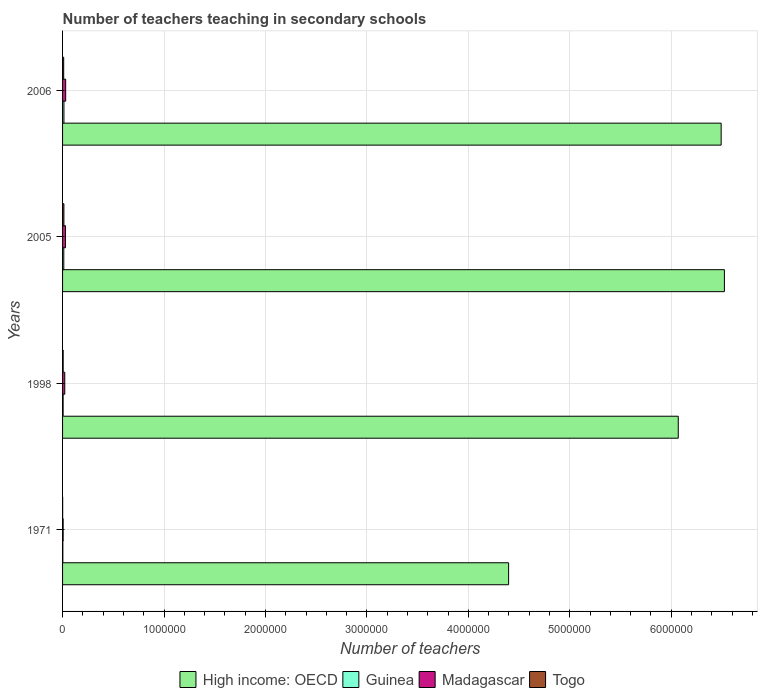How many different coloured bars are there?
Provide a short and direct response. 4. Are the number of bars per tick equal to the number of legend labels?
Give a very brief answer. Yes. Are the number of bars on each tick of the Y-axis equal?
Offer a terse response. Yes. What is the label of the 4th group of bars from the top?
Your answer should be compact. 1971. What is the number of teachers teaching in secondary schools in High income: OECD in 2005?
Give a very brief answer. 6.52e+06. Across all years, what is the maximum number of teachers teaching in secondary schools in Guinea?
Offer a terse response. 1.35e+04. Across all years, what is the minimum number of teachers teaching in secondary schools in Madagascar?
Your response must be concise. 5709. What is the total number of teachers teaching in secondary schools in Guinea in the graph?
Provide a short and direct response. 3.40e+04. What is the difference between the number of teachers teaching in secondary schools in Madagascar in 1998 and that in 2006?
Provide a succinct answer. -9016. What is the difference between the number of teachers teaching in secondary schools in Togo in 2006 and the number of teachers teaching in secondary schools in High income: OECD in 1998?
Ensure brevity in your answer.  -6.06e+06. What is the average number of teachers teaching in secondary schools in Guinea per year?
Your answer should be compact. 8506. In the year 2006, what is the difference between the number of teachers teaching in secondary schools in Madagascar and number of teachers teaching in secondary schools in Guinea?
Keep it short and to the point. 1.72e+04. In how many years, is the number of teachers teaching in secondary schools in Guinea greater than 4200000 ?
Ensure brevity in your answer.  0. What is the ratio of the number of teachers teaching in secondary schools in Togo in 2005 to that in 2006?
Provide a short and direct response. 1.2. Is the number of teachers teaching in secondary schools in Guinea in 1998 less than that in 2005?
Give a very brief answer. Yes. What is the difference between the highest and the second highest number of teachers teaching in secondary schools in High income: OECD?
Ensure brevity in your answer.  3.19e+04. What is the difference between the highest and the lowest number of teachers teaching in secondary schools in Togo?
Provide a short and direct response. 1.24e+04. Is it the case that in every year, the sum of the number of teachers teaching in secondary schools in Madagascar and number of teachers teaching in secondary schools in Togo is greater than the sum of number of teachers teaching in secondary schools in Guinea and number of teachers teaching in secondary schools in High income: OECD?
Make the answer very short. No. What does the 1st bar from the top in 1971 represents?
Make the answer very short. Togo. What does the 2nd bar from the bottom in 1971 represents?
Offer a terse response. Guinea. How many bars are there?
Your response must be concise. 16. How many years are there in the graph?
Give a very brief answer. 4. Does the graph contain any zero values?
Provide a short and direct response. No. Does the graph contain grids?
Your answer should be compact. Yes. Where does the legend appear in the graph?
Provide a succinct answer. Bottom center. What is the title of the graph?
Your answer should be very brief. Number of teachers teaching in secondary schools. What is the label or title of the X-axis?
Give a very brief answer. Number of teachers. What is the label or title of the Y-axis?
Offer a very short reply. Years. What is the Number of teachers of High income: OECD in 1971?
Make the answer very short. 4.40e+06. What is the Number of teachers in Guinea in 1971?
Your answer should be compact. 2785. What is the Number of teachers of Madagascar in 1971?
Your answer should be compact. 5709. What is the Number of teachers of Togo in 1971?
Your response must be concise. 880. What is the Number of teachers in High income: OECD in 1998?
Provide a succinct answer. 6.07e+06. What is the Number of teachers in Guinea in 1998?
Offer a very short reply. 5560. What is the Number of teachers in Madagascar in 1998?
Make the answer very short. 2.17e+04. What is the Number of teachers in Togo in 1998?
Offer a very short reply. 5962. What is the Number of teachers in High income: OECD in 2005?
Provide a short and direct response. 6.52e+06. What is the Number of teachers in Guinea in 2005?
Offer a terse response. 1.22e+04. What is the Number of teachers in Madagascar in 2005?
Provide a succinct answer. 2.88e+04. What is the Number of teachers of Togo in 2005?
Give a very brief answer. 1.33e+04. What is the Number of teachers of High income: OECD in 2006?
Keep it short and to the point. 6.49e+06. What is the Number of teachers of Guinea in 2006?
Provide a succinct answer. 1.35e+04. What is the Number of teachers in Madagascar in 2006?
Ensure brevity in your answer.  3.07e+04. What is the Number of teachers of Togo in 2006?
Provide a succinct answer. 1.11e+04. Across all years, what is the maximum Number of teachers in High income: OECD?
Ensure brevity in your answer.  6.52e+06. Across all years, what is the maximum Number of teachers in Guinea?
Make the answer very short. 1.35e+04. Across all years, what is the maximum Number of teachers of Madagascar?
Provide a short and direct response. 3.07e+04. Across all years, what is the maximum Number of teachers of Togo?
Provide a succinct answer. 1.33e+04. Across all years, what is the minimum Number of teachers of High income: OECD?
Your answer should be compact. 4.40e+06. Across all years, what is the minimum Number of teachers in Guinea?
Provide a succinct answer. 2785. Across all years, what is the minimum Number of teachers in Madagascar?
Keep it short and to the point. 5709. Across all years, what is the minimum Number of teachers of Togo?
Keep it short and to the point. 880. What is the total Number of teachers in High income: OECD in the graph?
Make the answer very short. 2.35e+07. What is the total Number of teachers in Guinea in the graph?
Make the answer very short. 3.40e+04. What is the total Number of teachers of Madagascar in the graph?
Provide a short and direct response. 8.69e+04. What is the total Number of teachers in Togo in the graph?
Offer a very short reply. 3.12e+04. What is the difference between the Number of teachers of High income: OECD in 1971 and that in 1998?
Offer a terse response. -1.67e+06. What is the difference between the Number of teachers in Guinea in 1971 and that in 1998?
Make the answer very short. -2775. What is the difference between the Number of teachers in Madagascar in 1971 and that in 1998?
Your answer should be very brief. -1.60e+04. What is the difference between the Number of teachers in Togo in 1971 and that in 1998?
Give a very brief answer. -5082. What is the difference between the Number of teachers of High income: OECD in 1971 and that in 2005?
Provide a short and direct response. -2.13e+06. What is the difference between the Number of teachers in Guinea in 1971 and that in 2005?
Give a very brief answer. -9417. What is the difference between the Number of teachers of Madagascar in 1971 and that in 2005?
Provide a short and direct response. -2.31e+04. What is the difference between the Number of teachers in Togo in 1971 and that in 2005?
Provide a short and direct response. -1.24e+04. What is the difference between the Number of teachers of High income: OECD in 1971 and that in 2006?
Offer a terse response. -2.10e+06. What is the difference between the Number of teachers of Guinea in 1971 and that in 2006?
Give a very brief answer. -1.07e+04. What is the difference between the Number of teachers in Madagascar in 1971 and that in 2006?
Provide a succinct answer. -2.50e+04. What is the difference between the Number of teachers in Togo in 1971 and that in 2006?
Give a very brief answer. -1.02e+04. What is the difference between the Number of teachers of High income: OECD in 1998 and that in 2005?
Your answer should be very brief. -4.55e+05. What is the difference between the Number of teachers in Guinea in 1998 and that in 2005?
Keep it short and to the point. -6642. What is the difference between the Number of teachers of Madagascar in 1998 and that in 2005?
Offer a terse response. -7148. What is the difference between the Number of teachers in Togo in 1998 and that in 2005?
Make the answer very short. -7297. What is the difference between the Number of teachers of High income: OECD in 1998 and that in 2006?
Ensure brevity in your answer.  -4.23e+05. What is the difference between the Number of teachers of Guinea in 1998 and that in 2006?
Keep it short and to the point. -7917. What is the difference between the Number of teachers of Madagascar in 1998 and that in 2006?
Provide a succinct answer. -9016. What is the difference between the Number of teachers of Togo in 1998 and that in 2006?
Provide a succinct answer. -5105. What is the difference between the Number of teachers in High income: OECD in 2005 and that in 2006?
Your answer should be very brief. 3.19e+04. What is the difference between the Number of teachers in Guinea in 2005 and that in 2006?
Keep it short and to the point. -1275. What is the difference between the Number of teachers in Madagascar in 2005 and that in 2006?
Ensure brevity in your answer.  -1868. What is the difference between the Number of teachers in Togo in 2005 and that in 2006?
Make the answer very short. 2192. What is the difference between the Number of teachers of High income: OECD in 1971 and the Number of teachers of Guinea in 1998?
Offer a very short reply. 4.39e+06. What is the difference between the Number of teachers of High income: OECD in 1971 and the Number of teachers of Madagascar in 1998?
Offer a very short reply. 4.38e+06. What is the difference between the Number of teachers of High income: OECD in 1971 and the Number of teachers of Togo in 1998?
Give a very brief answer. 4.39e+06. What is the difference between the Number of teachers in Guinea in 1971 and the Number of teachers in Madagascar in 1998?
Ensure brevity in your answer.  -1.89e+04. What is the difference between the Number of teachers of Guinea in 1971 and the Number of teachers of Togo in 1998?
Your answer should be compact. -3177. What is the difference between the Number of teachers in Madagascar in 1971 and the Number of teachers in Togo in 1998?
Provide a succinct answer. -253. What is the difference between the Number of teachers of High income: OECD in 1971 and the Number of teachers of Guinea in 2005?
Keep it short and to the point. 4.38e+06. What is the difference between the Number of teachers of High income: OECD in 1971 and the Number of teachers of Madagascar in 2005?
Ensure brevity in your answer.  4.37e+06. What is the difference between the Number of teachers in High income: OECD in 1971 and the Number of teachers in Togo in 2005?
Offer a very short reply. 4.38e+06. What is the difference between the Number of teachers of Guinea in 1971 and the Number of teachers of Madagascar in 2005?
Provide a succinct answer. -2.60e+04. What is the difference between the Number of teachers of Guinea in 1971 and the Number of teachers of Togo in 2005?
Offer a terse response. -1.05e+04. What is the difference between the Number of teachers in Madagascar in 1971 and the Number of teachers in Togo in 2005?
Ensure brevity in your answer.  -7550. What is the difference between the Number of teachers in High income: OECD in 1971 and the Number of teachers in Guinea in 2006?
Make the answer very short. 4.38e+06. What is the difference between the Number of teachers in High income: OECD in 1971 and the Number of teachers in Madagascar in 2006?
Ensure brevity in your answer.  4.37e+06. What is the difference between the Number of teachers of High income: OECD in 1971 and the Number of teachers of Togo in 2006?
Make the answer very short. 4.39e+06. What is the difference between the Number of teachers in Guinea in 1971 and the Number of teachers in Madagascar in 2006?
Your answer should be very brief. -2.79e+04. What is the difference between the Number of teachers in Guinea in 1971 and the Number of teachers in Togo in 2006?
Make the answer very short. -8282. What is the difference between the Number of teachers in Madagascar in 1971 and the Number of teachers in Togo in 2006?
Give a very brief answer. -5358. What is the difference between the Number of teachers of High income: OECD in 1998 and the Number of teachers of Guinea in 2005?
Offer a terse response. 6.06e+06. What is the difference between the Number of teachers of High income: OECD in 1998 and the Number of teachers of Madagascar in 2005?
Offer a very short reply. 6.04e+06. What is the difference between the Number of teachers in High income: OECD in 1998 and the Number of teachers in Togo in 2005?
Your answer should be very brief. 6.06e+06. What is the difference between the Number of teachers in Guinea in 1998 and the Number of teachers in Madagascar in 2005?
Make the answer very short. -2.33e+04. What is the difference between the Number of teachers of Guinea in 1998 and the Number of teachers of Togo in 2005?
Ensure brevity in your answer.  -7699. What is the difference between the Number of teachers of Madagascar in 1998 and the Number of teachers of Togo in 2005?
Offer a terse response. 8411. What is the difference between the Number of teachers of High income: OECD in 1998 and the Number of teachers of Guinea in 2006?
Offer a very short reply. 6.06e+06. What is the difference between the Number of teachers of High income: OECD in 1998 and the Number of teachers of Madagascar in 2006?
Your response must be concise. 6.04e+06. What is the difference between the Number of teachers of High income: OECD in 1998 and the Number of teachers of Togo in 2006?
Your answer should be very brief. 6.06e+06. What is the difference between the Number of teachers of Guinea in 1998 and the Number of teachers of Madagascar in 2006?
Give a very brief answer. -2.51e+04. What is the difference between the Number of teachers in Guinea in 1998 and the Number of teachers in Togo in 2006?
Ensure brevity in your answer.  -5507. What is the difference between the Number of teachers in Madagascar in 1998 and the Number of teachers in Togo in 2006?
Provide a succinct answer. 1.06e+04. What is the difference between the Number of teachers of High income: OECD in 2005 and the Number of teachers of Guinea in 2006?
Your response must be concise. 6.51e+06. What is the difference between the Number of teachers of High income: OECD in 2005 and the Number of teachers of Madagascar in 2006?
Offer a terse response. 6.49e+06. What is the difference between the Number of teachers of High income: OECD in 2005 and the Number of teachers of Togo in 2006?
Keep it short and to the point. 6.51e+06. What is the difference between the Number of teachers in Guinea in 2005 and the Number of teachers in Madagascar in 2006?
Your answer should be very brief. -1.85e+04. What is the difference between the Number of teachers in Guinea in 2005 and the Number of teachers in Togo in 2006?
Provide a short and direct response. 1135. What is the difference between the Number of teachers of Madagascar in 2005 and the Number of teachers of Togo in 2006?
Make the answer very short. 1.78e+04. What is the average Number of teachers of High income: OECD per year?
Keep it short and to the point. 5.87e+06. What is the average Number of teachers in Guinea per year?
Ensure brevity in your answer.  8506. What is the average Number of teachers of Madagascar per year?
Provide a short and direct response. 2.17e+04. What is the average Number of teachers of Togo per year?
Make the answer very short. 7792. In the year 1971, what is the difference between the Number of teachers of High income: OECD and Number of teachers of Guinea?
Offer a very short reply. 4.39e+06. In the year 1971, what is the difference between the Number of teachers of High income: OECD and Number of teachers of Madagascar?
Keep it short and to the point. 4.39e+06. In the year 1971, what is the difference between the Number of teachers in High income: OECD and Number of teachers in Togo?
Make the answer very short. 4.40e+06. In the year 1971, what is the difference between the Number of teachers of Guinea and Number of teachers of Madagascar?
Your response must be concise. -2924. In the year 1971, what is the difference between the Number of teachers in Guinea and Number of teachers in Togo?
Offer a terse response. 1905. In the year 1971, what is the difference between the Number of teachers in Madagascar and Number of teachers in Togo?
Give a very brief answer. 4829. In the year 1998, what is the difference between the Number of teachers in High income: OECD and Number of teachers in Guinea?
Your answer should be very brief. 6.06e+06. In the year 1998, what is the difference between the Number of teachers in High income: OECD and Number of teachers in Madagascar?
Your response must be concise. 6.05e+06. In the year 1998, what is the difference between the Number of teachers of High income: OECD and Number of teachers of Togo?
Your response must be concise. 6.06e+06. In the year 1998, what is the difference between the Number of teachers in Guinea and Number of teachers in Madagascar?
Your response must be concise. -1.61e+04. In the year 1998, what is the difference between the Number of teachers in Guinea and Number of teachers in Togo?
Ensure brevity in your answer.  -402. In the year 1998, what is the difference between the Number of teachers in Madagascar and Number of teachers in Togo?
Offer a terse response. 1.57e+04. In the year 2005, what is the difference between the Number of teachers in High income: OECD and Number of teachers in Guinea?
Offer a terse response. 6.51e+06. In the year 2005, what is the difference between the Number of teachers of High income: OECD and Number of teachers of Madagascar?
Offer a terse response. 6.50e+06. In the year 2005, what is the difference between the Number of teachers of High income: OECD and Number of teachers of Togo?
Give a very brief answer. 6.51e+06. In the year 2005, what is the difference between the Number of teachers of Guinea and Number of teachers of Madagascar?
Give a very brief answer. -1.66e+04. In the year 2005, what is the difference between the Number of teachers in Guinea and Number of teachers in Togo?
Provide a succinct answer. -1057. In the year 2005, what is the difference between the Number of teachers in Madagascar and Number of teachers in Togo?
Offer a terse response. 1.56e+04. In the year 2006, what is the difference between the Number of teachers in High income: OECD and Number of teachers in Guinea?
Provide a succinct answer. 6.48e+06. In the year 2006, what is the difference between the Number of teachers of High income: OECD and Number of teachers of Madagascar?
Provide a succinct answer. 6.46e+06. In the year 2006, what is the difference between the Number of teachers in High income: OECD and Number of teachers in Togo?
Offer a very short reply. 6.48e+06. In the year 2006, what is the difference between the Number of teachers in Guinea and Number of teachers in Madagascar?
Offer a terse response. -1.72e+04. In the year 2006, what is the difference between the Number of teachers in Guinea and Number of teachers in Togo?
Keep it short and to the point. 2410. In the year 2006, what is the difference between the Number of teachers in Madagascar and Number of teachers in Togo?
Your answer should be very brief. 1.96e+04. What is the ratio of the Number of teachers of High income: OECD in 1971 to that in 1998?
Your response must be concise. 0.72. What is the ratio of the Number of teachers in Guinea in 1971 to that in 1998?
Your answer should be compact. 0.5. What is the ratio of the Number of teachers in Madagascar in 1971 to that in 1998?
Give a very brief answer. 0.26. What is the ratio of the Number of teachers in Togo in 1971 to that in 1998?
Provide a short and direct response. 0.15. What is the ratio of the Number of teachers of High income: OECD in 1971 to that in 2005?
Ensure brevity in your answer.  0.67. What is the ratio of the Number of teachers of Guinea in 1971 to that in 2005?
Offer a very short reply. 0.23. What is the ratio of the Number of teachers of Madagascar in 1971 to that in 2005?
Make the answer very short. 0.2. What is the ratio of the Number of teachers in Togo in 1971 to that in 2005?
Your response must be concise. 0.07. What is the ratio of the Number of teachers of High income: OECD in 1971 to that in 2006?
Give a very brief answer. 0.68. What is the ratio of the Number of teachers in Guinea in 1971 to that in 2006?
Your answer should be compact. 0.21. What is the ratio of the Number of teachers of Madagascar in 1971 to that in 2006?
Make the answer very short. 0.19. What is the ratio of the Number of teachers in Togo in 1971 to that in 2006?
Keep it short and to the point. 0.08. What is the ratio of the Number of teachers in High income: OECD in 1998 to that in 2005?
Your answer should be very brief. 0.93. What is the ratio of the Number of teachers of Guinea in 1998 to that in 2005?
Your answer should be compact. 0.46. What is the ratio of the Number of teachers of Madagascar in 1998 to that in 2005?
Offer a very short reply. 0.75. What is the ratio of the Number of teachers of Togo in 1998 to that in 2005?
Make the answer very short. 0.45. What is the ratio of the Number of teachers in High income: OECD in 1998 to that in 2006?
Your answer should be compact. 0.93. What is the ratio of the Number of teachers in Guinea in 1998 to that in 2006?
Give a very brief answer. 0.41. What is the ratio of the Number of teachers in Madagascar in 1998 to that in 2006?
Make the answer very short. 0.71. What is the ratio of the Number of teachers in Togo in 1998 to that in 2006?
Make the answer very short. 0.54. What is the ratio of the Number of teachers of Guinea in 2005 to that in 2006?
Provide a short and direct response. 0.91. What is the ratio of the Number of teachers of Madagascar in 2005 to that in 2006?
Offer a very short reply. 0.94. What is the ratio of the Number of teachers in Togo in 2005 to that in 2006?
Your answer should be very brief. 1.2. What is the difference between the highest and the second highest Number of teachers in High income: OECD?
Give a very brief answer. 3.19e+04. What is the difference between the highest and the second highest Number of teachers in Guinea?
Your answer should be compact. 1275. What is the difference between the highest and the second highest Number of teachers of Madagascar?
Provide a succinct answer. 1868. What is the difference between the highest and the second highest Number of teachers of Togo?
Provide a short and direct response. 2192. What is the difference between the highest and the lowest Number of teachers in High income: OECD?
Provide a short and direct response. 2.13e+06. What is the difference between the highest and the lowest Number of teachers in Guinea?
Offer a terse response. 1.07e+04. What is the difference between the highest and the lowest Number of teachers of Madagascar?
Provide a short and direct response. 2.50e+04. What is the difference between the highest and the lowest Number of teachers in Togo?
Your answer should be compact. 1.24e+04. 